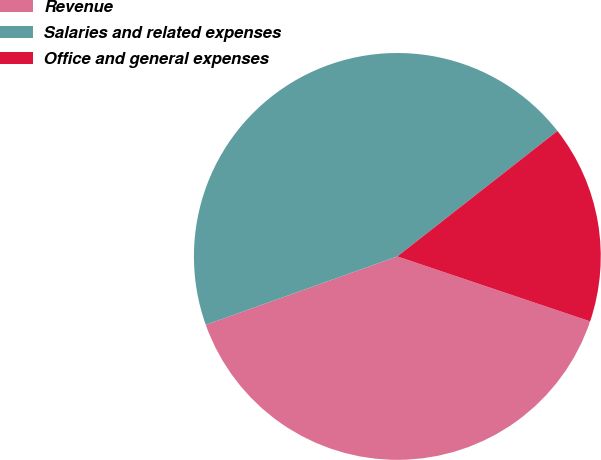Convert chart. <chart><loc_0><loc_0><loc_500><loc_500><pie_chart><fcel>Revenue<fcel>Salaries and related expenses<fcel>Office and general expenses<nl><fcel>39.37%<fcel>44.88%<fcel>15.75%<nl></chart> 